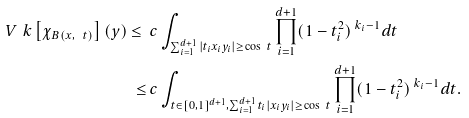<formula> <loc_0><loc_0><loc_500><loc_500>V _ { \ } k \left [ \chi _ { B ( x , \ t ) } \right ] ( y ) \leq \ & c \int _ { \sum _ { i = 1 } ^ { d + 1 } | t _ { i } x _ { i } y _ { i } | \geq \cos \ t } \prod _ { i = 1 } ^ { d + 1 } ( 1 - t _ { i } ^ { 2 } ) ^ { \ k _ { i } - 1 } d t \\ \leq \ & c \int _ { t \in [ 0 , 1 ] ^ { d + 1 } , \sum _ { i = 1 } ^ { d + 1 } t _ { i } | x _ { i } y _ { i } | \geq \cos \ t } \prod _ { i = 1 } ^ { d + 1 } ( 1 - t _ { i } ^ { 2 } ) ^ { \ k _ { i } - 1 } d t .</formula> 